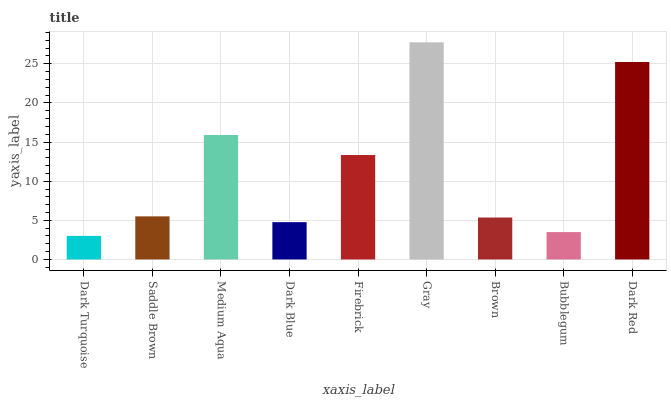Is Dark Turquoise the minimum?
Answer yes or no. Yes. Is Gray the maximum?
Answer yes or no. Yes. Is Saddle Brown the minimum?
Answer yes or no. No. Is Saddle Brown the maximum?
Answer yes or no. No. Is Saddle Brown greater than Dark Turquoise?
Answer yes or no. Yes. Is Dark Turquoise less than Saddle Brown?
Answer yes or no. Yes. Is Dark Turquoise greater than Saddle Brown?
Answer yes or no. No. Is Saddle Brown less than Dark Turquoise?
Answer yes or no. No. Is Saddle Brown the high median?
Answer yes or no. Yes. Is Saddle Brown the low median?
Answer yes or no. Yes. Is Dark Turquoise the high median?
Answer yes or no. No. Is Dark Red the low median?
Answer yes or no. No. 